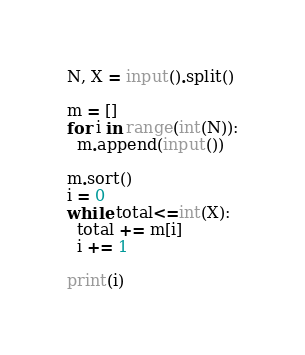<code> <loc_0><loc_0><loc_500><loc_500><_Python_>N, X = input().split()

m = []
for i in range(int(N)):
  m.append(input())
  
m.sort()
i = 0
while total<=int(X):
  total += m[i]
  i += 1
  
print(i)</code> 